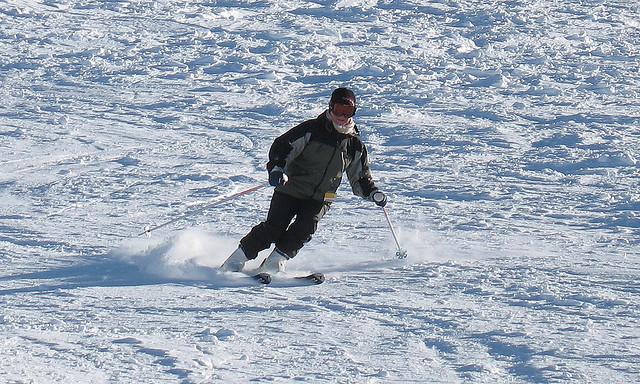What is in the snow?
Answer briefly. Skier. Is this the first person to ski in this snow?
Concise answer only. No. Which direction is the man leaning?
Keep it brief. Left. Is this surfing?
Answer briefly. No. 